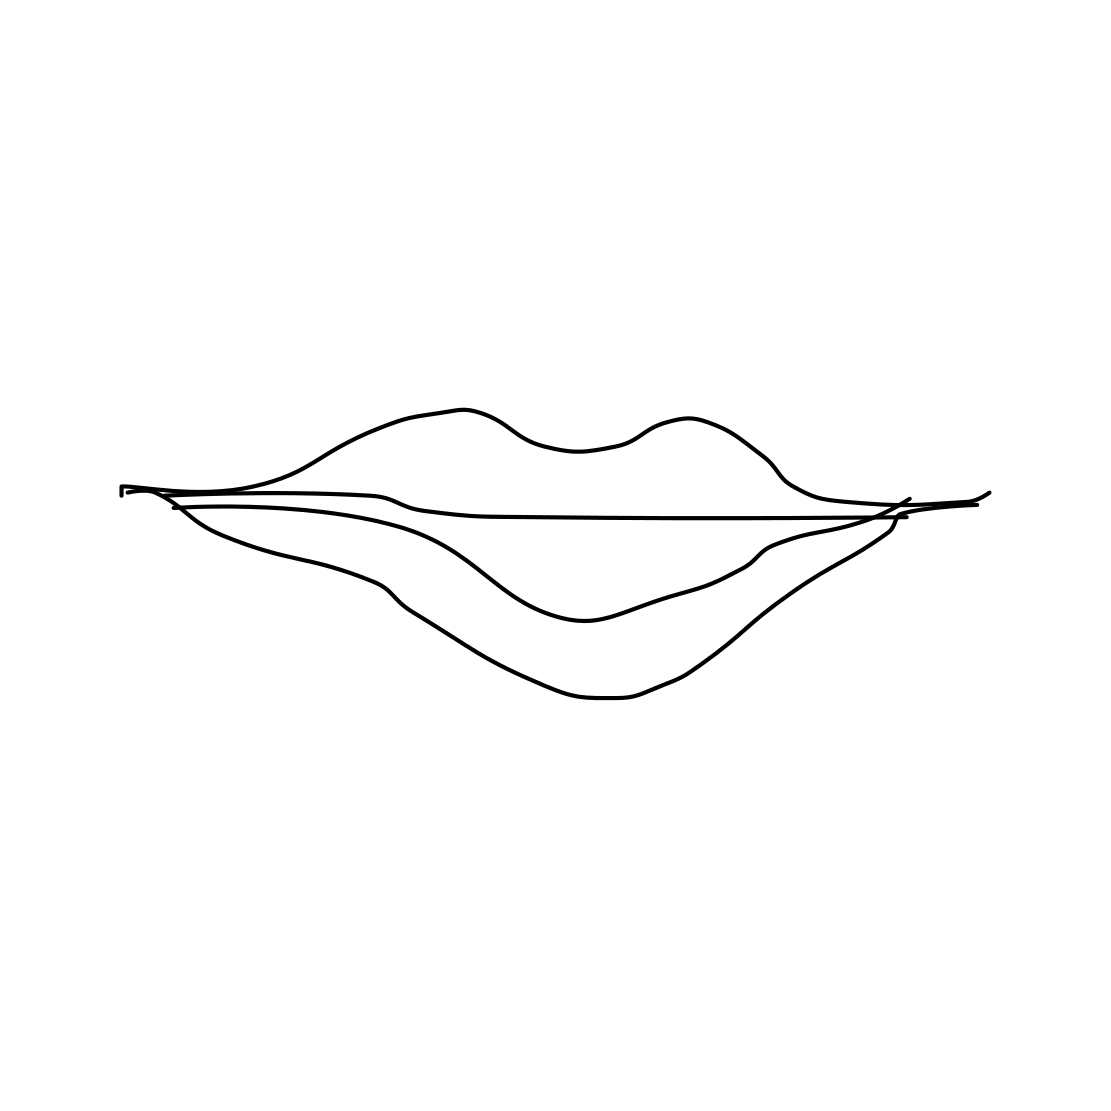Is there a sketchy present in the picture? There are no items or symbols that could be interpreted as a 'sketchy present' in the picture. Instead, the image features a simple line drawing of a pair of lips, portrayed in a minimalist and stylized fashion. 